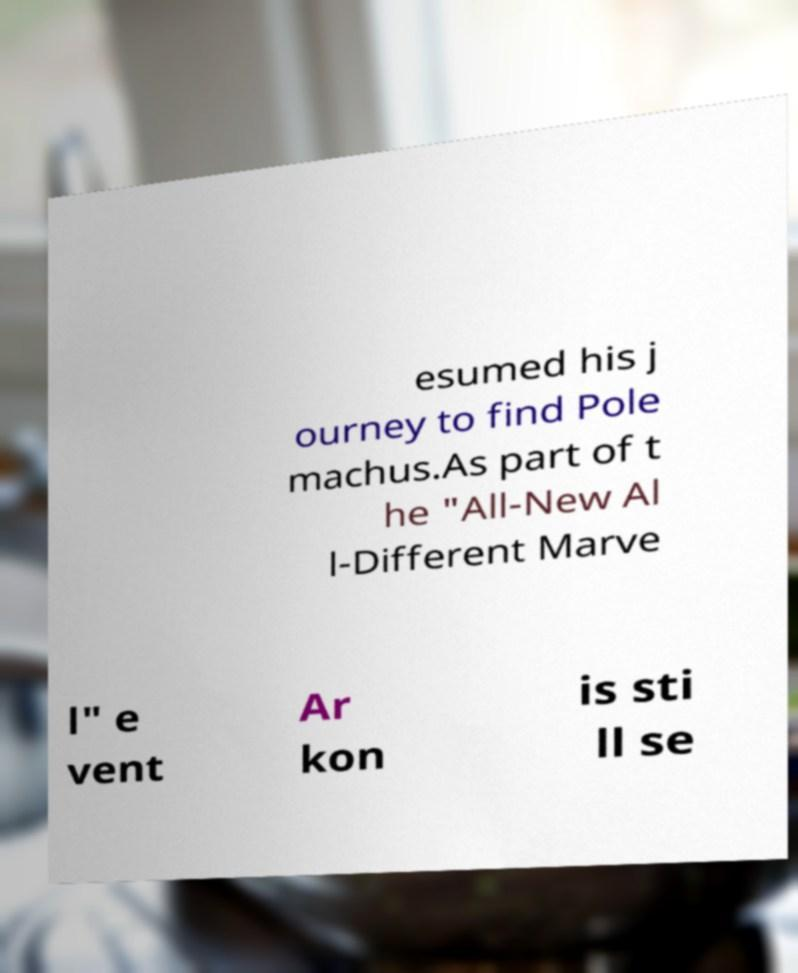What messages or text are displayed in this image? I need them in a readable, typed format. esumed his j ourney to find Pole machus.As part of t he "All-New Al l-Different Marve l" e vent Ar kon is sti ll se 